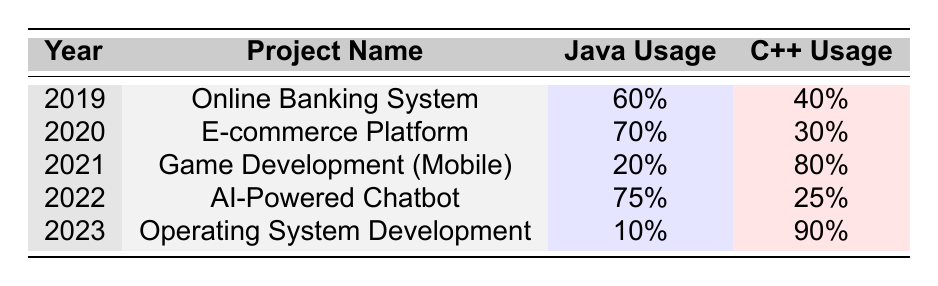What was the Java usage percentage in the Online Banking System project? The table shows the row for the Online Banking System project in 2019, where the Java usage is listed as 60%.
Answer: 60% In which year was Java usage the highest? By examining the table, the highest Java usage percentage is 75%, which occurs in the year 2022 for the AI-Powered Chatbot project.
Answer: 2022 What was the difference in C++ usage between Game Development (Mobile) and AI-Powered Chatbot? For Game Development (Mobile) in 2021, C++ usage was 80%, while for AI-Powered Chatbot in 2022, it was 25%. The difference is 80% - 25% = 55%.
Answer: 55% Was C++ usage over 50% in any project in 2023? In the table, C++ usage for the Operating System Development project in 2023 is 90%, which is over 50%. Therefore, the answer is yes.
Answer: Yes What is the average Java usage across all projects from 2019 to 2023? The Java usage percentages are 60%, 70%, 20%, 75%, and 10% for the five projects. To find the average, sum them up: 60 + 70 + 20 + 75 + 10 = 235. Then divide by the number of projects, which is 5: 235 / 5 = 47.
Answer: 47 In which project did C++ usage drop the most compared to the previous year? By reviewing the C++ usage percentages, Online Banking System (2019) had 40%, then E-commerce Platform (2020) dropped to 30%, a decrease of 10%. In 2021, Game Development (Mobile) used 80%, which compared to 30% for E-commerce Platform shows a drop of 50%. Therefore, the most significant drop occurred there.
Answer: Game Development (Mobile) Which project had the lowest overall usage of Java and C++ combined? The combined usage of Java and C++ for each project must be calculated: for 2019, it is 100% (60% + 40%); 2020 is 100%; 2021 is 100%; 2022 is 100%; and 2023 is 100%. Therefore, there is no project with lower combined usage since they all sum to 100%.
Answer: None What trend can be observed in Java and C++ usage from 2019 to 2023? By observing the table, we can see that Java usage decreases from 60% in 2019 to 10% in 2023, while C++ usage increases from 40% to 90%. This trend indicates a clear shift towards greater C++ adoption over time.
Answer: Java decreases, C++ increases 